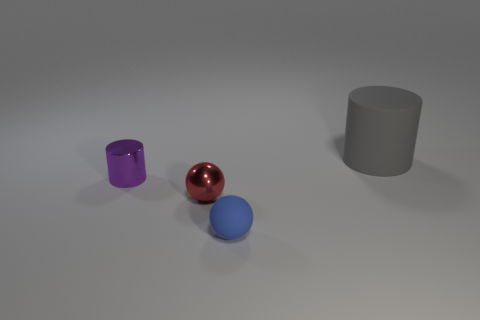There is a shiny thing behind the red ball; does it have the same size as the red metal ball?
Your answer should be compact. Yes. What material is the tiny cylinder?
Give a very brief answer. Metal. The cylinder right of the small metal cylinder is what color?
Your answer should be very brief. Gray. How many small things are purple metal objects or gray things?
Give a very brief answer. 1. Is the color of the shiny thing behind the tiny red metallic ball the same as the thing that is in front of the red object?
Your response must be concise. No. What number of other objects are there of the same color as the large cylinder?
Ensure brevity in your answer.  0. What number of gray things are shiny cylinders or blocks?
Provide a short and direct response. 0. There is a small blue thing; is its shape the same as the tiny shiny thing that is on the left side of the tiny red metal ball?
Offer a very short reply. No. There is a blue object; what shape is it?
Ensure brevity in your answer.  Sphere. What is the material of the ball that is the same size as the red object?
Provide a short and direct response. Rubber. 